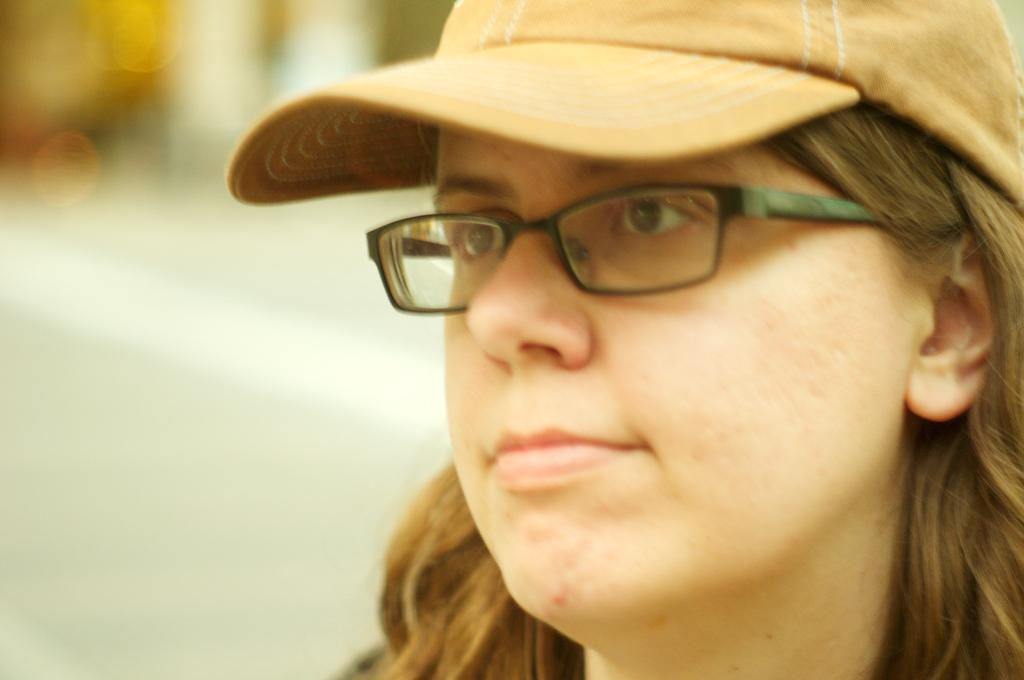Who is present in the image? There is a woman in the image. What is the woman wearing on her head? The woman is wearing a cap. What accessory is the woman wearing on her face? The woman is wearing spectacles. Can you describe the background of the image? The background of the image is blurry. How many bears are visible in the image? There are no bears present in the image. What type of cable can be seen connecting the woman to the background? There is no cable visible in the image, and the woman is not connected to the background. 